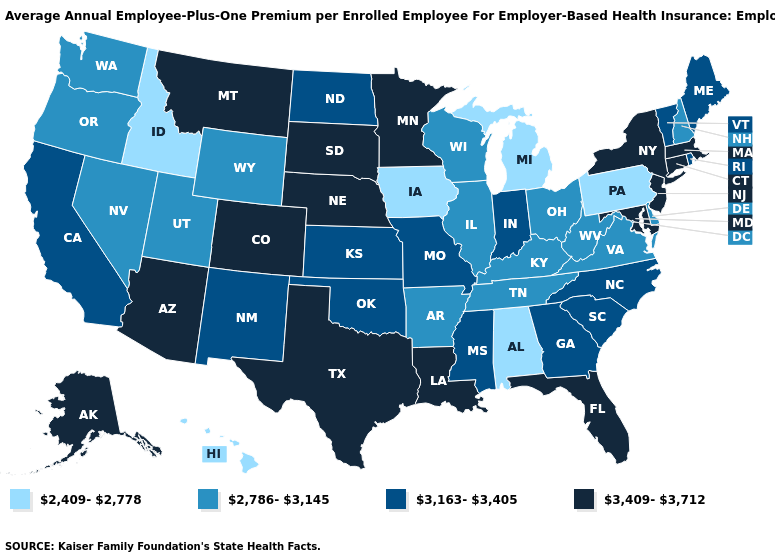Which states have the highest value in the USA?
Keep it brief. Alaska, Arizona, Colorado, Connecticut, Florida, Louisiana, Maryland, Massachusetts, Minnesota, Montana, Nebraska, New Jersey, New York, South Dakota, Texas. What is the value of Wisconsin?
Concise answer only. 2,786-3,145. What is the highest value in the Northeast ?
Be succinct. 3,409-3,712. Does Kentucky have the lowest value in the South?
Answer briefly. No. What is the value of Hawaii?
Concise answer only. 2,409-2,778. What is the value of New Hampshire?
Quick response, please. 2,786-3,145. What is the highest value in the USA?
Write a very short answer. 3,409-3,712. Name the states that have a value in the range 3,409-3,712?
Write a very short answer. Alaska, Arizona, Colorado, Connecticut, Florida, Louisiana, Maryland, Massachusetts, Minnesota, Montana, Nebraska, New Jersey, New York, South Dakota, Texas. What is the value of Oregon?
Concise answer only. 2,786-3,145. Does Alabama have the lowest value in the USA?
Give a very brief answer. Yes. Name the states that have a value in the range 2,409-2,778?
Short answer required. Alabama, Hawaii, Idaho, Iowa, Michigan, Pennsylvania. Does the map have missing data?
Quick response, please. No. What is the highest value in the USA?
Give a very brief answer. 3,409-3,712. Among the states that border Mississippi , does Louisiana have the highest value?
Answer briefly. Yes. Name the states that have a value in the range 3,163-3,405?
Write a very short answer. California, Georgia, Indiana, Kansas, Maine, Mississippi, Missouri, New Mexico, North Carolina, North Dakota, Oklahoma, Rhode Island, South Carolina, Vermont. 